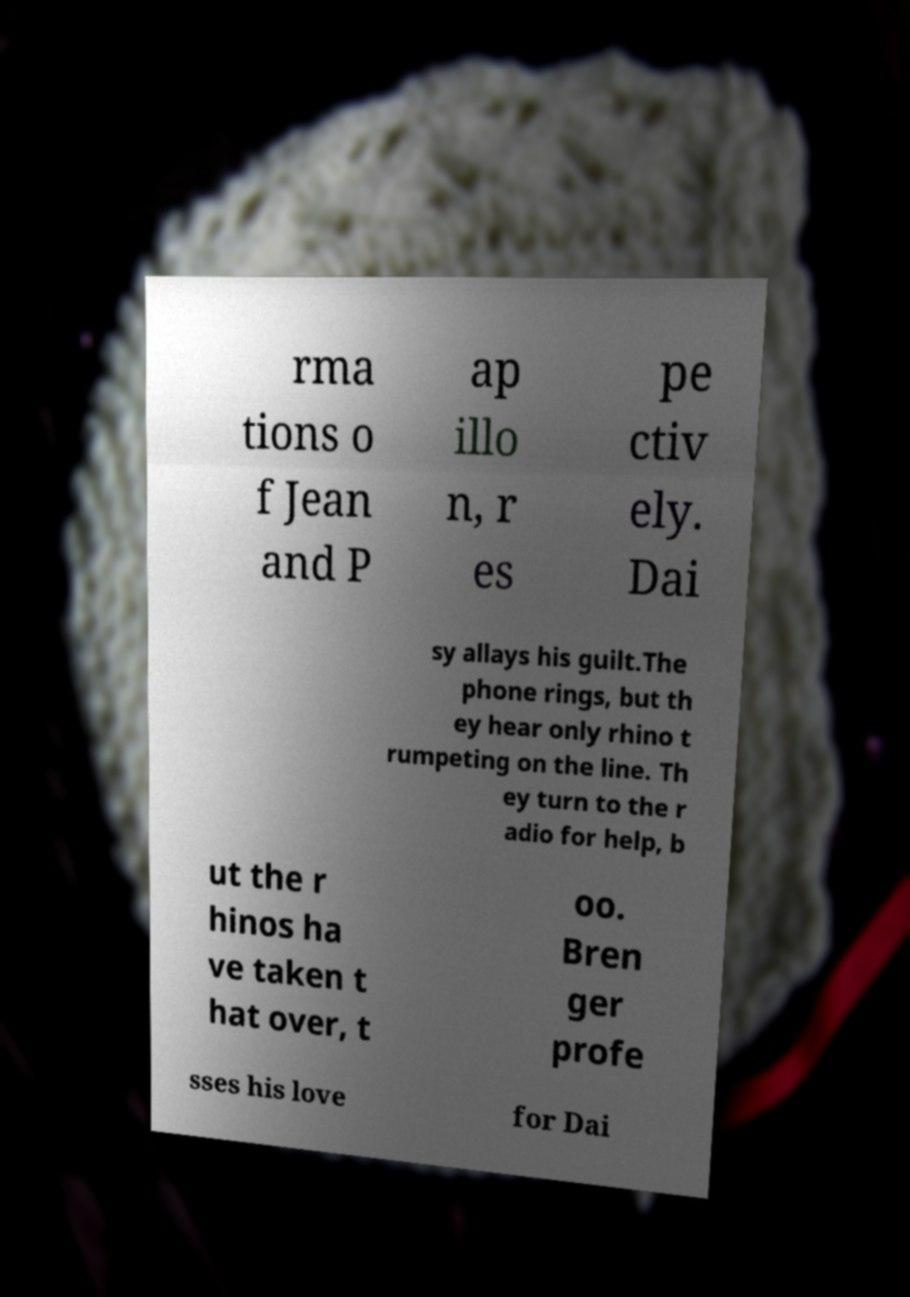I need the written content from this picture converted into text. Can you do that? rma tions o f Jean and P ap illo n, r es pe ctiv ely. Dai sy allays his guilt.The phone rings, but th ey hear only rhino t rumpeting on the line. Th ey turn to the r adio for help, b ut the r hinos ha ve taken t hat over, t oo. Bren ger profe sses his love for Dai 